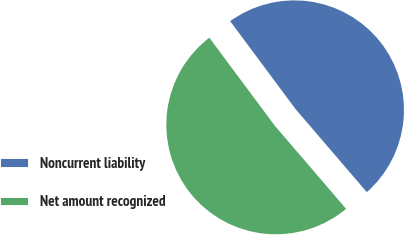Convert chart to OTSL. <chart><loc_0><loc_0><loc_500><loc_500><pie_chart><fcel>Noncurrent liability<fcel>Net amount recognized<nl><fcel>48.9%<fcel>51.1%<nl></chart> 